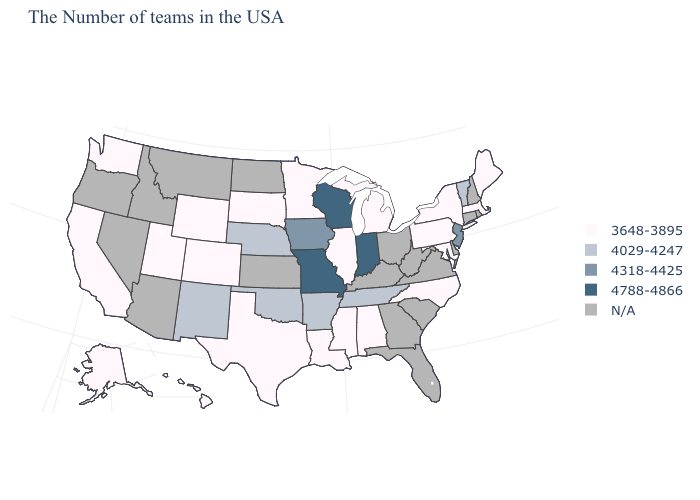What is the lowest value in the Northeast?
Answer briefly. 3648-3895. What is the value of Missouri?
Quick response, please. 4788-4866. What is the lowest value in the USA?
Keep it brief. 3648-3895. Does the map have missing data?
Keep it brief. Yes. What is the lowest value in the USA?
Write a very short answer. 3648-3895. What is the value of Maine?
Short answer required. 3648-3895. Name the states that have a value in the range 3648-3895?
Concise answer only. Maine, Massachusetts, New York, Maryland, Pennsylvania, North Carolina, Michigan, Alabama, Illinois, Mississippi, Louisiana, Minnesota, Texas, South Dakota, Wyoming, Colorado, Utah, California, Washington, Alaska, Hawaii. Does New Mexico have the lowest value in the West?
Be succinct. No. What is the value of Wyoming?
Write a very short answer. 3648-3895. Among the states that border Iowa , which have the lowest value?
Quick response, please. Illinois, Minnesota, South Dakota. Among the states that border Ohio , does Michigan have the lowest value?
Write a very short answer. Yes. Does the map have missing data?
Give a very brief answer. Yes. How many symbols are there in the legend?
Be succinct. 5. 